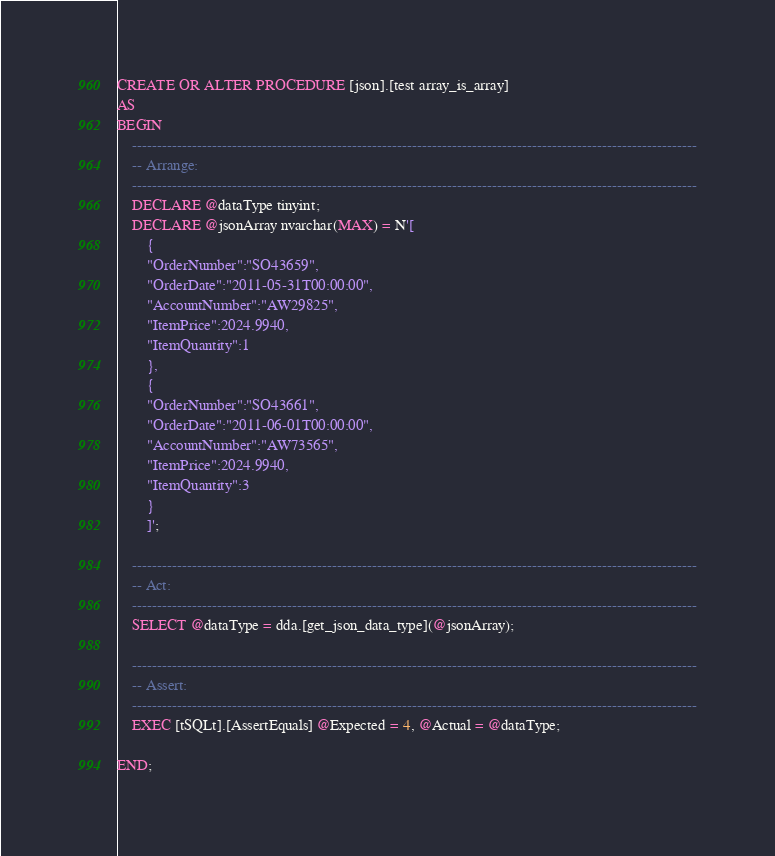<code> <loc_0><loc_0><loc_500><loc_500><_SQL_>
CREATE OR ALTER PROCEDURE [json].[test array_is_array]
AS
BEGIN
  	-----------------------------------------------------------------------------------------------------------------
	-- Arrange:
	-----------------------------------------------------------------------------------------------------------------
	DECLARE @dataType tinyint;
	DECLARE @jsonArray nvarchar(MAX) = N'[
		{
		"OrderNumber":"SO43659",
		"OrderDate":"2011-05-31T00:00:00",
		"AccountNumber":"AW29825",
		"ItemPrice":2024.9940,
		"ItemQuantity":1
		},
		{
		"OrderNumber":"SO43661",
		"OrderDate":"2011-06-01T00:00:00",
		"AccountNumber":"AW73565",
		"ItemPrice":2024.9940,
		"ItemQuantity":3
		}
		]';

	-----------------------------------------------------------------------------------------------------------------
	-- Act: 
	-----------------------------------------------------------------------------------------------------------------
	SELECT @dataType = dda.[get_json_data_type](@jsonArray);

	-----------------------------------------------------------------------------------------------------------------
	-- Assert: 
	-----------------------------------------------------------------------------------------------------------------
	EXEC [tSQLt].[AssertEquals] @Expected = 4, @Actual = @dataType;

END;
</code> 